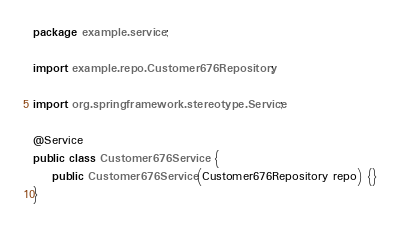<code> <loc_0><loc_0><loc_500><loc_500><_Java_>package example.service;

import example.repo.Customer676Repository;

import org.springframework.stereotype.Service;

@Service
public class Customer676Service {
	public Customer676Service(Customer676Repository repo) {}
}
</code> 